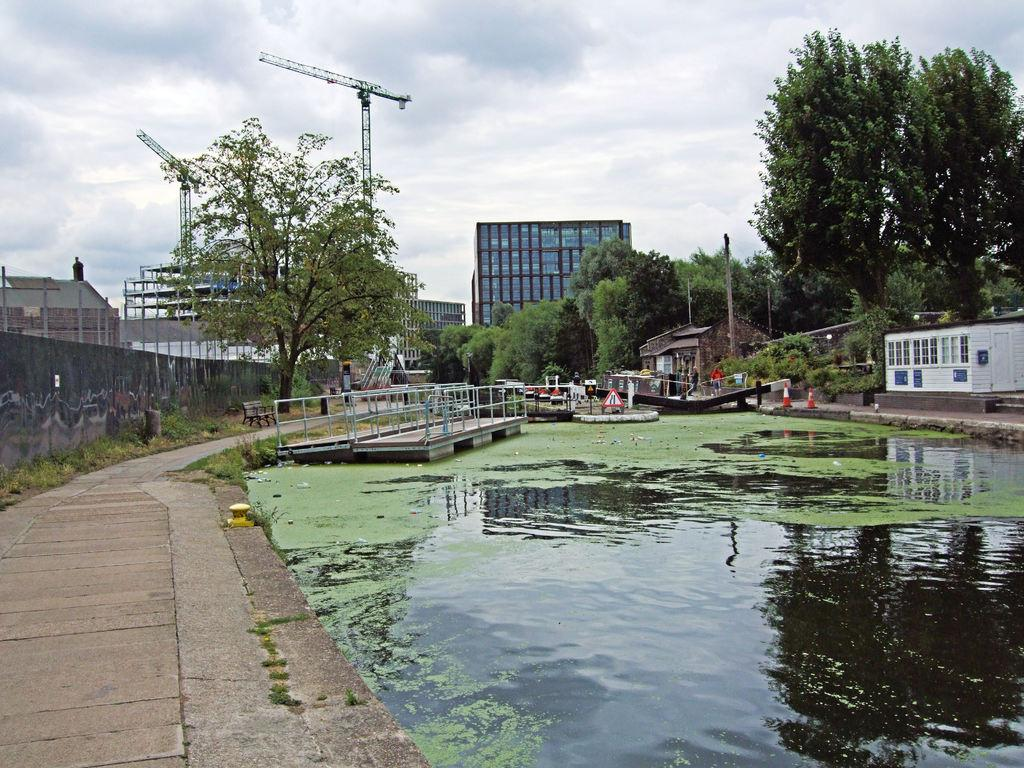What type of water body is visible in the image? There is a pond in the image. What type of surface is present near the pond? There is a pavement in the image. What can be seen in the background of the image? Trees and buildings are present in the background of the image. What is the condition of the sky in the image? The sky is covered with clouds. What type of operation is being performed on the note in the image? There is no note present in the image, so no operation can be performed on it. What type of gardening tool is visible in the image? There is no gardening tool, such as a spade, present in the image. 